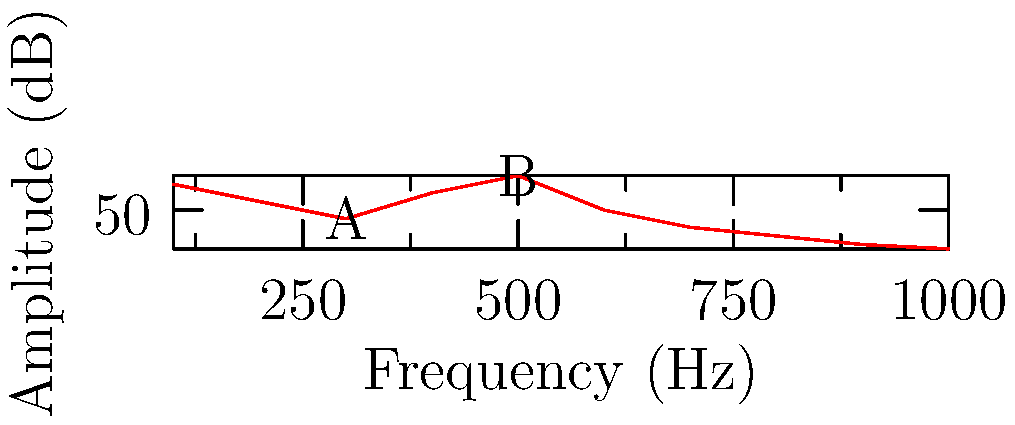In the frequency spectrum graph of an audio sample, two prominent peaks are labeled A and B. If peak A occurs at 300 Hz and peak B at 500 Hz, what is the likely fundamental frequency of the recorded sound, assuming these are harmonics? To determine the fundamental frequency, we need to follow these steps:

1. Identify the frequencies of the peaks:
   Peak A: 300 Hz
   Peak B: 500 Hz

2. Determine if these frequencies are harmonics:
   Harmonics are integer multiples of the fundamental frequency.

3. Find the greatest common divisor (GCD) of the peak frequencies:
   GCD(300, 500) = 100 Hz

4. Check if the GCD is a common factor:
   300 Hz = 3 * 100 Hz
   500 Hz = 5 * 100 Hz

5. Verify that other visible peaks in the spectrum align with multiples of 100 Hz.

6. Conclude that 100 Hz is likely the fundamental frequency, as it's the highest common factor that explains both observed peaks as harmonics (3rd and 5th harmonics, respectively).
Answer: 100 Hz 